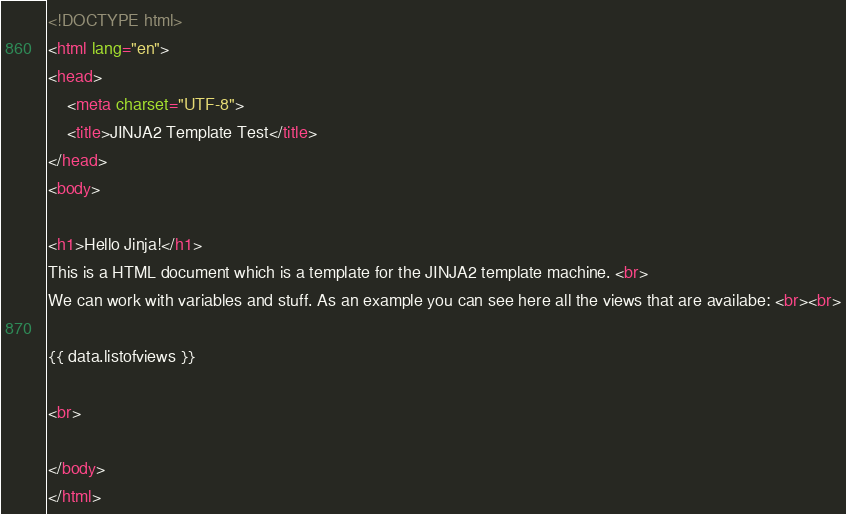<code> <loc_0><loc_0><loc_500><loc_500><_HTML_><!DOCTYPE html>
<html lang="en">
<head>
    <meta charset="UTF-8">
    <title>JINJA2 Template Test</title>
</head>
<body>

<h1>Hello Jinja!</h1>
This is a HTML document which is a template for the JINJA2 template machine. <br>
We can work with variables and stuff. As an example you can see here all the views that are availabe: <br><br>

{{ data.listofviews }}

<br>

</body>
</html></code> 